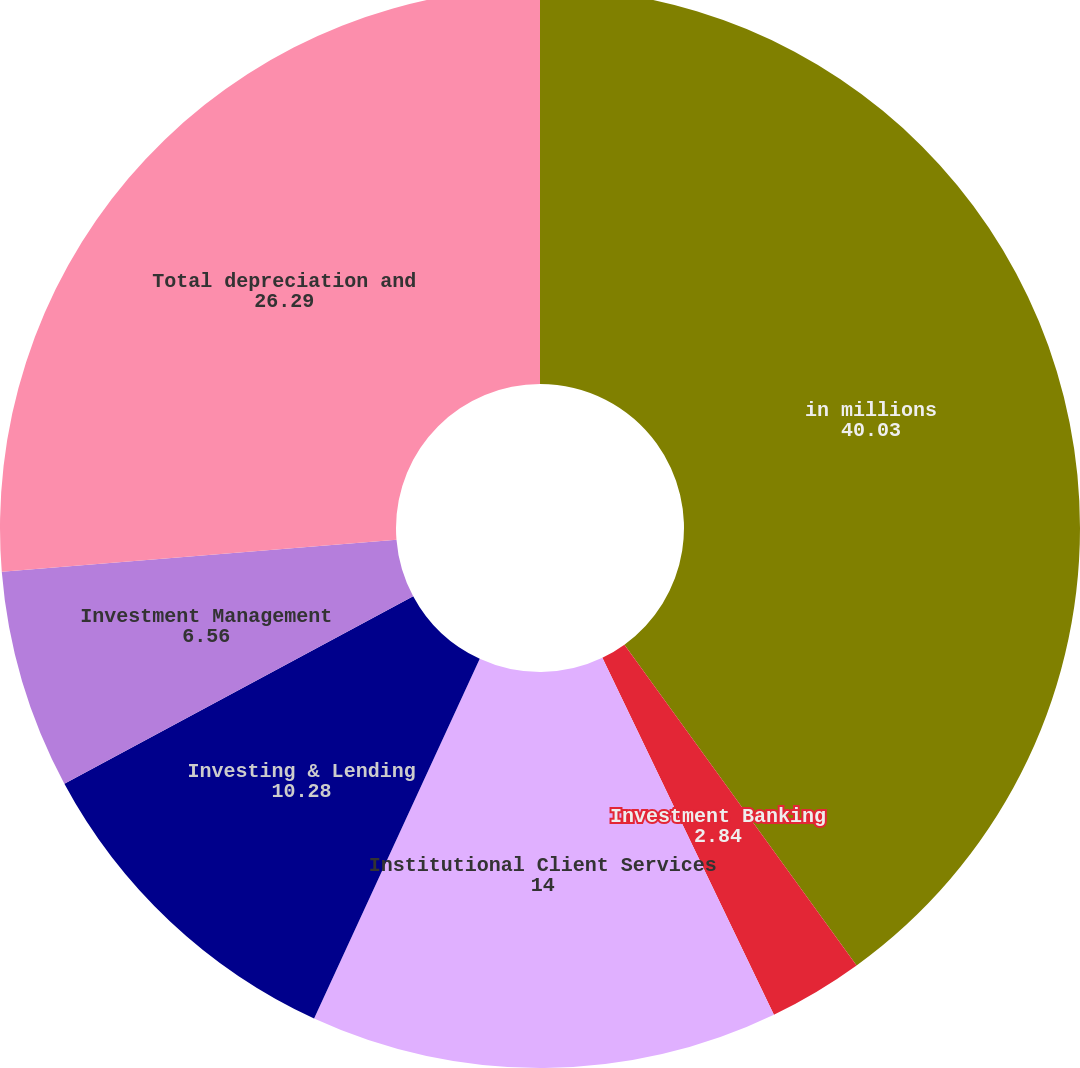<chart> <loc_0><loc_0><loc_500><loc_500><pie_chart><fcel>in millions<fcel>Investment Banking<fcel>Institutional Client Services<fcel>Investing & Lending<fcel>Investment Management<fcel>Total depreciation and<nl><fcel>40.03%<fcel>2.84%<fcel>14.0%<fcel>10.28%<fcel>6.56%<fcel>26.29%<nl></chart> 